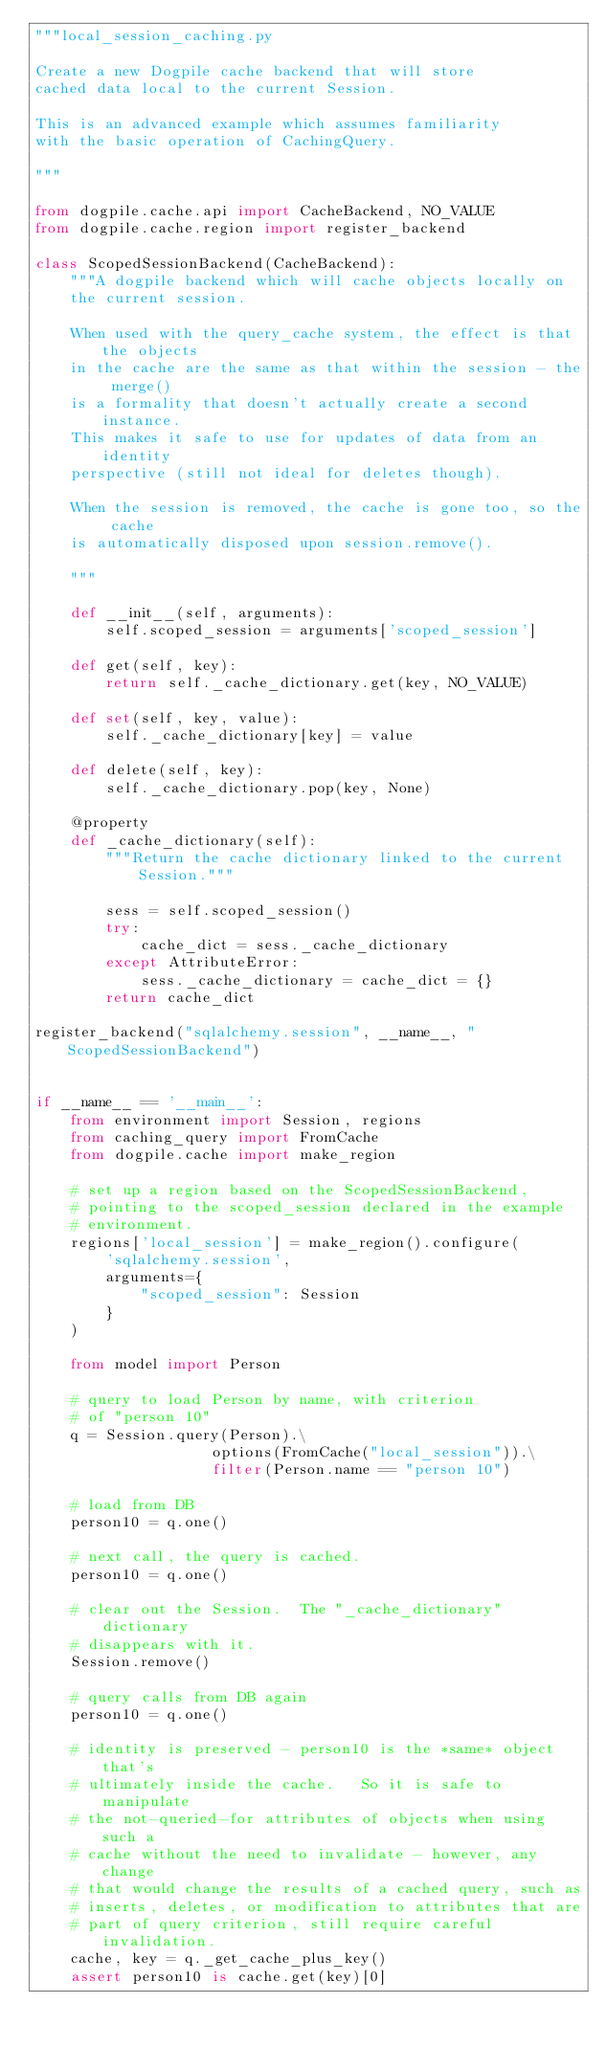Convert code to text. <code><loc_0><loc_0><loc_500><loc_500><_Python_>"""local_session_caching.py

Create a new Dogpile cache backend that will store
cached data local to the current Session.

This is an advanced example which assumes familiarity
with the basic operation of CachingQuery.

"""

from dogpile.cache.api import CacheBackend, NO_VALUE
from dogpile.cache.region import register_backend

class ScopedSessionBackend(CacheBackend):
    """A dogpile backend which will cache objects locally on
    the current session.

    When used with the query_cache system, the effect is that the objects
    in the cache are the same as that within the session - the merge()
    is a formality that doesn't actually create a second instance.
    This makes it safe to use for updates of data from an identity
    perspective (still not ideal for deletes though).

    When the session is removed, the cache is gone too, so the cache
    is automatically disposed upon session.remove().

    """

    def __init__(self, arguments):
        self.scoped_session = arguments['scoped_session']

    def get(self, key):
        return self._cache_dictionary.get(key, NO_VALUE)

    def set(self, key, value):
        self._cache_dictionary[key] = value

    def delete(self, key):
        self._cache_dictionary.pop(key, None)

    @property
    def _cache_dictionary(self):
        """Return the cache dictionary linked to the current Session."""

        sess = self.scoped_session()
        try:
            cache_dict = sess._cache_dictionary
        except AttributeError:
            sess._cache_dictionary = cache_dict = {}
        return cache_dict

register_backend("sqlalchemy.session", __name__, "ScopedSessionBackend")


if __name__ == '__main__':
    from environment import Session, regions
    from caching_query import FromCache
    from dogpile.cache import make_region

    # set up a region based on the ScopedSessionBackend,
    # pointing to the scoped_session declared in the example
    # environment.
    regions['local_session'] = make_region().configure(
        'sqlalchemy.session',
        arguments={
            "scoped_session": Session
        }
    )

    from model import Person

    # query to load Person by name, with criterion
    # of "person 10"
    q = Session.query(Person).\
                    options(FromCache("local_session")).\
                    filter(Person.name == "person 10")

    # load from DB
    person10 = q.one()

    # next call, the query is cached.
    person10 = q.one()

    # clear out the Session.  The "_cache_dictionary" dictionary
    # disappears with it.
    Session.remove()

    # query calls from DB again
    person10 = q.one()

    # identity is preserved - person10 is the *same* object that's
    # ultimately inside the cache.   So it is safe to manipulate
    # the not-queried-for attributes of objects when using such a
    # cache without the need to invalidate - however, any change
    # that would change the results of a cached query, such as
    # inserts, deletes, or modification to attributes that are
    # part of query criterion, still require careful invalidation.
    cache, key = q._get_cache_plus_key()
    assert person10 is cache.get(key)[0]
</code> 